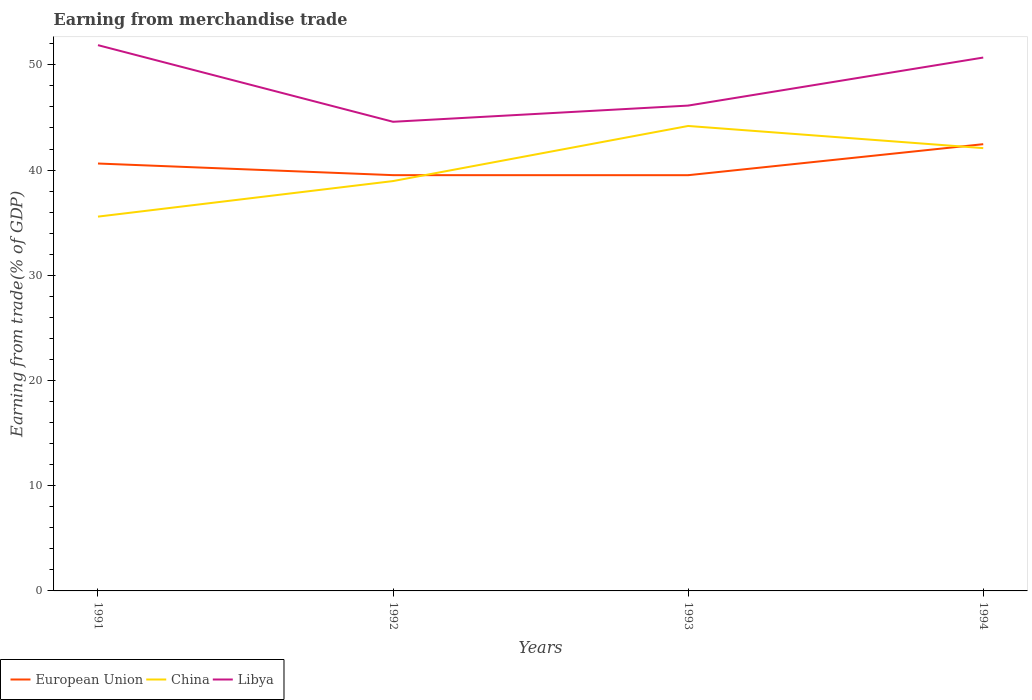Does the line corresponding to China intersect with the line corresponding to Libya?
Make the answer very short. No. Is the number of lines equal to the number of legend labels?
Give a very brief answer. Yes. Across all years, what is the maximum earnings from trade in China?
Your answer should be compact. 35.57. What is the total earnings from trade in Libya in the graph?
Offer a terse response. 7.28. What is the difference between the highest and the second highest earnings from trade in Libya?
Offer a terse response. 7.28. What is the difference between two consecutive major ticks on the Y-axis?
Keep it short and to the point. 10. Does the graph contain grids?
Provide a short and direct response. No. Where does the legend appear in the graph?
Your answer should be very brief. Bottom left. How are the legend labels stacked?
Keep it short and to the point. Horizontal. What is the title of the graph?
Your response must be concise. Earning from merchandise trade. What is the label or title of the Y-axis?
Offer a terse response. Earning from trade(% of GDP). What is the Earning from trade(% of GDP) of European Union in 1991?
Your answer should be compact. 40.62. What is the Earning from trade(% of GDP) in China in 1991?
Your answer should be very brief. 35.57. What is the Earning from trade(% of GDP) in Libya in 1991?
Keep it short and to the point. 51.87. What is the Earning from trade(% of GDP) of European Union in 1992?
Offer a very short reply. 39.52. What is the Earning from trade(% of GDP) in China in 1992?
Give a very brief answer. 38.95. What is the Earning from trade(% of GDP) of Libya in 1992?
Your answer should be compact. 44.59. What is the Earning from trade(% of GDP) in European Union in 1993?
Ensure brevity in your answer.  39.51. What is the Earning from trade(% of GDP) of China in 1993?
Your response must be concise. 44.19. What is the Earning from trade(% of GDP) of Libya in 1993?
Give a very brief answer. 46.13. What is the Earning from trade(% of GDP) in European Union in 1994?
Give a very brief answer. 42.46. What is the Earning from trade(% of GDP) of China in 1994?
Offer a terse response. 42.08. What is the Earning from trade(% of GDP) of Libya in 1994?
Your response must be concise. 50.69. Across all years, what is the maximum Earning from trade(% of GDP) in European Union?
Provide a succinct answer. 42.46. Across all years, what is the maximum Earning from trade(% of GDP) of China?
Keep it short and to the point. 44.19. Across all years, what is the maximum Earning from trade(% of GDP) of Libya?
Make the answer very short. 51.87. Across all years, what is the minimum Earning from trade(% of GDP) in European Union?
Provide a short and direct response. 39.51. Across all years, what is the minimum Earning from trade(% of GDP) in China?
Your answer should be very brief. 35.57. Across all years, what is the minimum Earning from trade(% of GDP) of Libya?
Provide a short and direct response. 44.59. What is the total Earning from trade(% of GDP) in European Union in the graph?
Provide a succinct answer. 162.11. What is the total Earning from trade(% of GDP) of China in the graph?
Your answer should be very brief. 160.8. What is the total Earning from trade(% of GDP) in Libya in the graph?
Provide a short and direct response. 193.28. What is the difference between the Earning from trade(% of GDP) of European Union in 1991 and that in 1992?
Your answer should be compact. 1.11. What is the difference between the Earning from trade(% of GDP) in China in 1991 and that in 1992?
Give a very brief answer. -3.38. What is the difference between the Earning from trade(% of GDP) in Libya in 1991 and that in 1992?
Provide a succinct answer. 7.28. What is the difference between the Earning from trade(% of GDP) in European Union in 1991 and that in 1993?
Offer a very short reply. 1.11. What is the difference between the Earning from trade(% of GDP) of China in 1991 and that in 1993?
Provide a short and direct response. -8.61. What is the difference between the Earning from trade(% of GDP) of Libya in 1991 and that in 1993?
Offer a terse response. 5.74. What is the difference between the Earning from trade(% of GDP) in European Union in 1991 and that in 1994?
Keep it short and to the point. -1.84. What is the difference between the Earning from trade(% of GDP) in China in 1991 and that in 1994?
Make the answer very short. -6.51. What is the difference between the Earning from trade(% of GDP) of Libya in 1991 and that in 1994?
Offer a terse response. 1.18. What is the difference between the Earning from trade(% of GDP) of European Union in 1992 and that in 1993?
Make the answer very short. 0. What is the difference between the Earning from trade(% of GDP) in China in 1992 and that in 1993?
Your response must be concise. -5.24. What is the difference between the Earning from trade(% of GDP) of Libya in 1992 and that in 1993?
Your response must be concise. -1.54. What is the difference between the Earning from trade(% of GDP) in European Union in 1992 and that in 1994?
Your answer should be very brief. -2.94. What is the difference between the Earning from trade(% of GDP) in China in 1992 and that in 1994?
Give a very brief answer. -3.13. What is the difference between the Earning from trade(% of GDP) of Libya in 1992 and that in 1994?
Offer a terse response. -6.1. What is the difference between the Earning from trade(% of GDP) in European Union in 1993 and that in 1994?
Provide a succinct answer. -2.95. What is the difference between the Earning from trade(% of GDP) in China in 1993 and that in 1994?
Provide a short and direct response. 2.11. What is the difference between the Earning from trade(% of GDP) in Libya in 1993 and that in 1994?
Give a very brief answer. -4.57. What is the difference between the Earning from trade(% of GDP) in European Union in 1991 and the Earning from trade(% of GDP) in China in 1992?
Your response must be concise. 1.67. What is the difference between the Earning from trade(% of GDP) in European Union in 1991 and the Earning from trade(% of GDP) in Libya in 1992?
Make the answer very short. -3.97. What is the difference between the Earning from trade(% of GDP) in China in 1991 and the Earning from trade(% of GDP) in Libya in 1992?
Ensure brevity in your answer.  -9.01. What is the difference between the Earning from trade(% of GDP) in European Union in 1991 and the Earning from trade(% of GDP) in China in 1993?
Ensure brevity in your answer.  -3.57. What is the difference between the Earning from trade(% of GDP) of European Union in 1991 and the Earning from trade(% of GDP) of Libya in 1993?
Make the answer very short. -5.51. What is the difference between the Earning from trade(% of GDP) in China in 1991 and the Earning from trade(% of GDP) in Libya in 1993?
Provide a succinct answer. -10.55. What is the difference between the Earning from trade(% of GDP) of European Union in 1991 and the Earning from trade(% of GDP) of China in 1994?
Your response must be concise. -1.46. What is the difference between the Earning from trade(% of GDP) of European Union in 1991 and the Earning from trade(% of GDP) of Libya in 1994?
Your answer should be very brief. -10.07. What is the difference between the Earning from trade(% of GDP) of China in 1991 and the Earning from trade(% of GDP) of Libya in 1994?
Your answer should be very brief. -15.12. What is the difference between the Earning from trade(% of GDP) of European Union in 1992 and the Earning from trade(% of GDP) of China in 1993?
Your answer should be compact. -4.67. What is the difference between the Earning from trade(% of GDP) in European Union in 1992 and the Earning from trade(% of GDP) in Libya in 1993?
Offer a very short reply. -6.61. What is the difference between the Earning from trade(% of GDP) of China in 1992 and the Earning from trade(% of GDP) of Libya in 1993?
Ensure brevity in your answer.  -7.17. What is the difference between the Earning from trade(% of GDP) in European Union in 1992 and the Earning from trade(% of GDP) in China in 1994?
Ensure brevity in your answer.  -2.57. What is the difference between the Earning from trade(% of GDP) in European Union in 1992 and the Earning from trade(% of GDP) in Libya in 1994?
Give a very brief answer. -11.18. What is the difference between the Earning from trade(% of GDP) in China in 1992 and the Earning from trade(% of GDP) in Libya in 1994?
Your response must be concise. -11.74. What is the difference between the Earning from trade(% of GDP) of European Union in 1993 and the Earning from trade(% of GDP) of China in 1994?
Make the answer very short. -2.57. What is the difference between the Earning from trade(% of GDP) of European Union in 1993 and the Earning from trade(% of GDP) of Libya in 1994?
Give a very brief answer. -11.18. What is the difference between the Earning from trade(% of GDP) of China in 1993 and the Earning from trade(% of GDP) of Libya in 1994?
Your response must be concise. -6.5. What is the average Earning from trade(% of GDP) of European Union per year?
Ensure brevity in your answer.  40.53. What is the average Earning from trade(% of GDP) of China per year?
Offer a very short reply. 40.2. What is the average Earning from trade(% of GDP) of Libya per year?
Make the answer very short. 48.32. In the year 1991, what is the difference between the Earning from trade(% of GDP) in European Union and Earning from trade(% of GDP) in China?
Ensure brevity in your answer.  5.05. In the year 1991, what is the difference between the Earning from trade(% of GDP) in European Union and Earning from trade(% of GDP) in Libya?
Give a very brief answer. -11.25. In the year 1991, what is the difference between the Earning from trade(% of GDP) in China and Earning from trade(% of GDP) in Libya?
Offer a very short reply. -16.3. In the year 1992, what is the difference between the Earning from trade(% of GDP) of European Union and Earning from trade(% of GDP) of China?
Your answer should be compact. 0.56. In the year 1992, what is the difference between the Earning from trade(% of GDP) in European Union and Earning from trade(% of GDP) in Libya?
Your answer should be compact. -5.07. In the year 1992, what is the difference between the Earning from trade(% of GDP) in China and Earning from trade(% of GDP) in Libya?
Offer a very short reply. -5.63. In the year 1993, what is the difference between the Earning from trade(% of GDP) of European Union and Earning from trade(% of GDP) of China?
Offer a very short reply. -4.68. In the year 1993, what is the difference between the Earning from trade(% of GDP) of European Union and Earning from trade(% of GDP) of Libya?
Provide a succinct answer. -6.62. In the year 1993, what is the difference between the Earning from trade(% of GDP) of China and Earning from trade(% of GDP) of Libya?
Your answer should be very brief. -1.94. In the year 1994, what is the difference between the Earning from trade(% of GDP) in European Union and Earning from trade(% of GDP) in China?
Offer a terse response. 0.38. In the year 1994, what is the difference between the Earning from trade(% of GDP) in European Union and Earning from trade(% of GDP) in Libya?
Ensure brevity in your answer.  -8.23. In the year 1994, what is the difference between the Earning from trade(% of GDP) of China and Earning from trade(% of GDP) of Libya?
Offer a terse response. -8.61. What is the ratio of the Earning from trade(% of GDP) in European Union in 1991 to that in 1992?
Keep it short and to the point. 1.03. What is the ratio of the Earning from trade(% of GDP) in China in 1991 to that in 1992?
Your answer should be very brief. 0.91. What is the ratio of the Earning from trade(% of GDP) of Libya in 1991 to that in 1992?
Provide a succinct answer. 1.16. What is the ratio of the Earning from trade(% of GDP) in European Union in 1991 to that in 1993?
Your answer should be very brief. 1.03. What is the ratio of the Earning from trade(% of GDP) in China in 1991 to that in 1993?
Provide a short and direct response. 0.81. What is the ratio of the Earning from trade(% of GDP) of Libya in 1991 to that in 1993?
Offer a terse response. 1.12. What is the ratio of the Earning from trade(% of GDP) in European Union in 1991 to that in 1994?
Offer a terse response. 0.96. What is the ratio of the Earning from trade(% of GDP) of China in 1991 to that in 1994?
Your answer should be very brief. 0.85. What is the ratio of the Earning from trade(% of GDP) of Libya in 1991 to that in 1994?
Give a very brief answer. 1.02. What is the ratio of the Earning from trade(% of GDP) in European Union in 1992 to that in 1993?
Your response must be concise. 1. What is the ratio of the Earning from trade(% of GDP) in China in 1992 to that in 1993?
Your answer should be compact. 0.88. What is the ratio of the Earning from trade(% of GDP) of Libya in 1992 to that in 1993?
Your response must be concise. 0.97. What is the ratio of the Earning from trade(% of GDP) in European Union in 1992 to that in 1994?
Provide a short and direct response. 0.93. What is the ratio of the Earning from trade(% of GDP) of China in 1992 to that in 1994?
Provide a short and direct response. 0.93. What is the ratio of the Earning from trade(% of GDP) of Libya in 1992 to that in 1994?
Provide a short and direct response. 0.88. What is the ratio of the Earning from trade(% of GDP) in European Union in 1993 to that in 1994?
Your answer should be very brief. 0.93. What is the ratio of the Earning from trade(% of GDP) in Libya in 1993 to that in 1994?
Provide a succinct answer. 0.91. What is the difference between the highest and the second highest Earning from trade(% of GDP) in European Union?
Your answer should be compact. 1.84. What is the difference between the highest and the second highest Earning from trade(% of GDP) in China?
Offer a very short reply. 2.11. What is the difference between the highest and the second highest Earning from trade(% of GDP) in Libya?
Make the answer very short. 1.18. What is the difference between the highest and the lowest Earning from trade(% of GDP) of European Union?
Your response must be concise. 2.95. What is the difference between the highest and the lowest Earning from trade(% of GDP) in China?
Offer a very short reply. 8.61. What is the difference between the highest and the lowest Earning from trade(% of GDP) of Libya?
Keep it short and to the point. 7.28. 